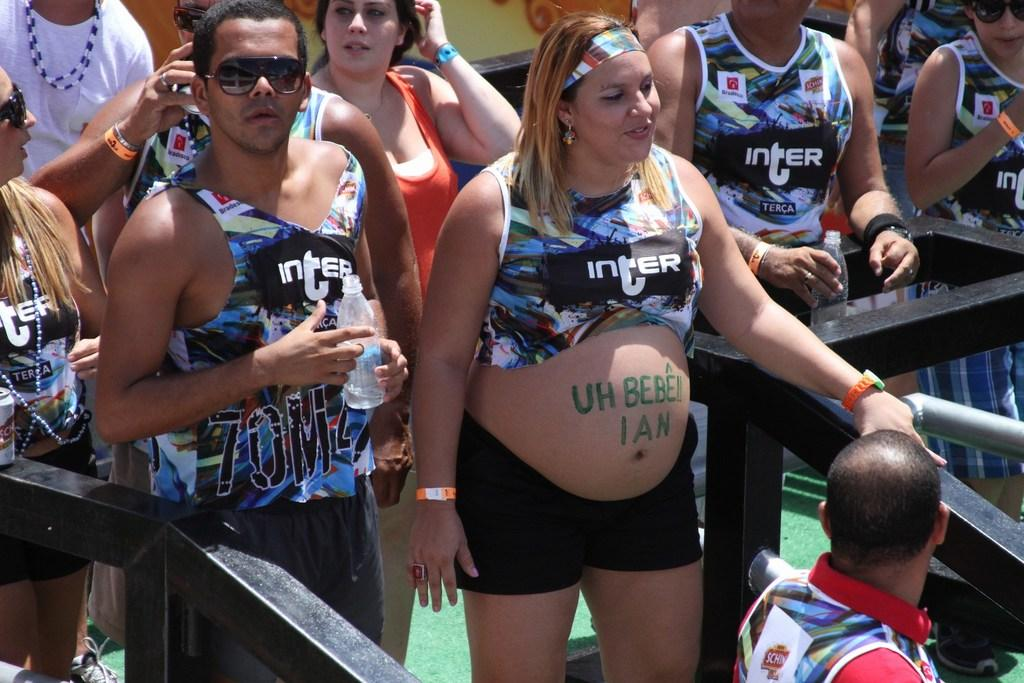<image>
Provide a brief description of the given image. A group of people in Inter tank tops around a pregnant woman who has written on her belly Uh Bebe Ian. 